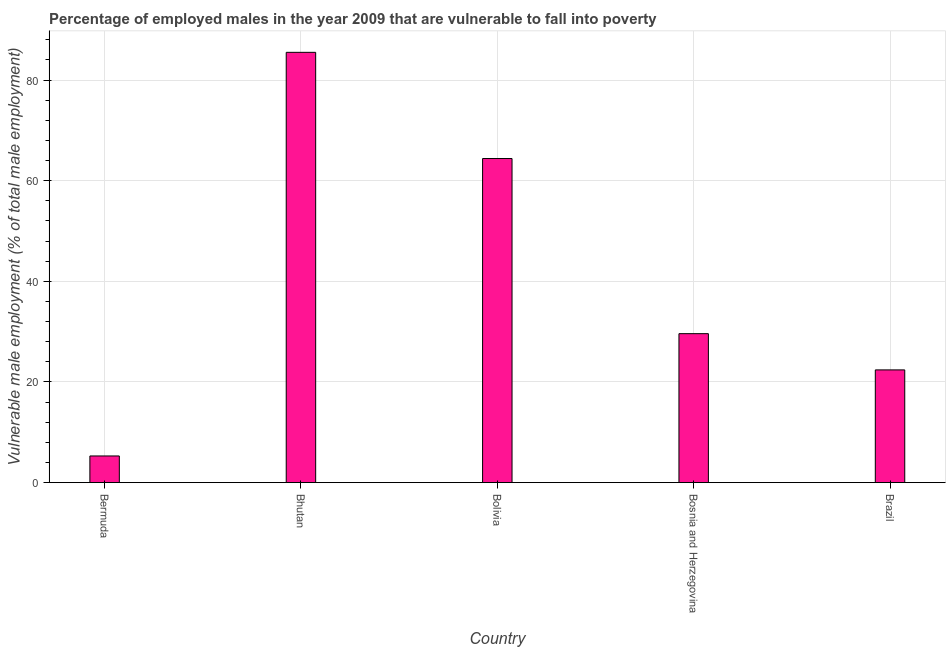Does the graph contain any zero values?
Keep it short and to the point. No. Does the graph contain grids?
Keep it short and to the point. Yes. What is the title of the graph?
Keep it short and to the point. Percentage of employed males in the year 2009 that are vulnerable to fall into poverty. What is the label or title of the X-axis?
Give a very brief answer. Country. What is the label or title of the Y-axis?
Your response must be concise. Vulnerable male employment (% of total male employment). What is the percentage of employed males who are vulnerable to fall into poverty in Bosnia and Herzegovina?
Provide a short and direct response. 29.6. Across all countries, what is the maximum percentage of employed males who are vulnerable to fall into poverty?
Offer a terse response. 85.5. Across all countries, what is the minimum percentage of employed males who are vulnerable to fall into poverty?
Offer a terse response. 5.3. In which country was the percentage of employed males who are vulnerable to fall into poverty maximum?
Offer a very short reply. Bhutan. In which country was the percentage of employed males who are vulnerable to fall into poverty minimum?
Offer a very short reply. Bermuda. What is the sum of the percentage of employed males who are vulnerable to fall into poverty?
Give a very brief answer. 207.2. What is the difference between the percentage of employed males who are vulnerable to fall into poverty in Bermuda and Bhutan?
Offer a terse response. -80.2. What is the average percentage of employed males who are vulnerable to fall into poverty per country?
Ensure brevity in your answer.  41.44. What is the median percentage of employed males who are vulnerable to fall into poverty?
Make the answer very short. 29.6. What is the ratio of the percentage of employed males who are vulnerable to fall into poverty in Bolivia to that in Bosnia and Herzegovina?
Your answer should be compact. 2.18. Is the difference between the percentage of employed males who are vulnerable to fall into poverty in Bhutan and Bolivia greater than the difference between any two countries?
Offer a terse response. No. What is the difference between the highest and the second highest percentage of employed males who are vulnerable to fall into poverty?
Your response must be concise. 21.1. What is the difference between the highest and the lowest percentage of employed males who are vulnerable to fall into poverty?
Provide a succinct answer. 80.2. In how many countries, is the percentage of employed males who are vulnerable to fall into poverty greater than the average percentage of employed males who are vulnerable to fall into poverty taken over all countries?
Your answer should be very brief. 2. Are all the bars in the graph horizontal?
Offer a terse response. No. What is the Vulnerable male employment (% of total male employment) in Bermuda?
Keep it short and to the point. 5.3. What is the Vulnerable male employment (% of total male employment) of Bhutan?
Keep it short and to the point. 85.5. What is the Vulnerable male employment (% of total male employment) of Bolivia?
Your answer should be very brief. 64.4. What is the Vulnerable male employment (% of total male employment) of Bosnia and Herzegovina?
Your answer should be compact. 29.6. What is the Vulnerable male employment (% of total male employment) in Brazil?
Ensure brevity in your answer.  22.4. What is the difference between the Vulnerable male employment (% of total male employment) in Bermuda and Bhutan?
Keep it short and to the point. -80.2. What is the difference between the Vulnerable male employment (% of total male employment) in Bermuda and Bolivia?
Your response must be concise. -59.1. What is the difference between the Vulnerable male employment (% of total male employment) in Bermuda and Bosnia and Herzegovina?
Your response must be concise. -24.3. What is the difference between the Vulnerable male employment (% of total male employment) in Bermuda and Brazil?
Your response must be concise. -17.1. What is the difference between the Vulnerable male employment (% of total male employment) in Bhutan and Bolivia?
Ensure brevity in your answer.  21.1. What is the difference between the Vulnerable male employment (% of total male employment) in Bhutan and Bosnia and Herzegovina?
Your response must be concise. 55.9. What is the difference between the Vulnerable male employment (% of total male employment) in Bhutan and Brazil?
Your answer should be very brief. 63.1. What is the difference between the Vulnerable male employment (% of total male employment) in Bolivia and Bosnia and Herzegovina?
Ensure brevity in your answer.  34.8. What is the ratio of the Vulnerable male employment (% of total male employment) in Bermuda to that in Bhutan?
Your response must be concise. 0.06. What is the ratio of the Vulnerable male employment (% of total male employment) in Bermuda to that in Bolivia?
Provide a succinct answer. 0.08. What is the ratio of the Vulnerable male employment (% of total male employment) in Bermuda to that in Bosnia and Herzegovina?
Ensure brevity in your answer.  0.18. What is the ratio of the Vulnerable male employment (% of total male employment) in Bermuda to that in Brazil?
Your answer should be very brief. 0.24. What is the ratio of the Vulnerable male employment (% of total male employment) in Bhutan to that in Bolivia?
Give a very brief answer. 1.33. What is the ratio of the Vulnerable male employment (% of total male employment) in Bhutan to that in Bosnia and Herzegovina?
Your response must be concise. 2.89. What is the ratio of the Vulnerable male employment (% of total male employment) in Bhutan to that in Brazil?
Your answer should be compact. 3.82. What is the ratio of the Vulnerable male employment (% of total male employment) in Bolivia to that in Bosnia and Herzegovina?
Make the answer very short. 2.18. What is the ratio of the Vulnerable male employment (% of total male employment) in Bolivia to that in Brazil?
Give a very brief answer. 2.88. What is the ratio of the Vulnerable male employment (% of total male employment) in Bosnia and Herzegovina to that in Brazil?
Your answer should be compact. 1.32. 